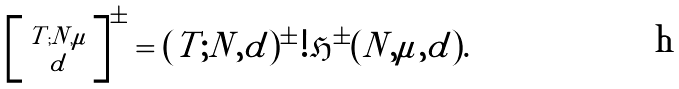<formula> <loc_0><loc_0><loc_500><loc_500>\left [ \begin{smallmatrix} T ; N , \mu \\ d \end{smallmatrix} \right ] ^ { \pm } = ( T ; N , d ) ^ { \pm } ! \mathfrak { H } ^ { \pm } ( N , \mu , d ) .</formula> 